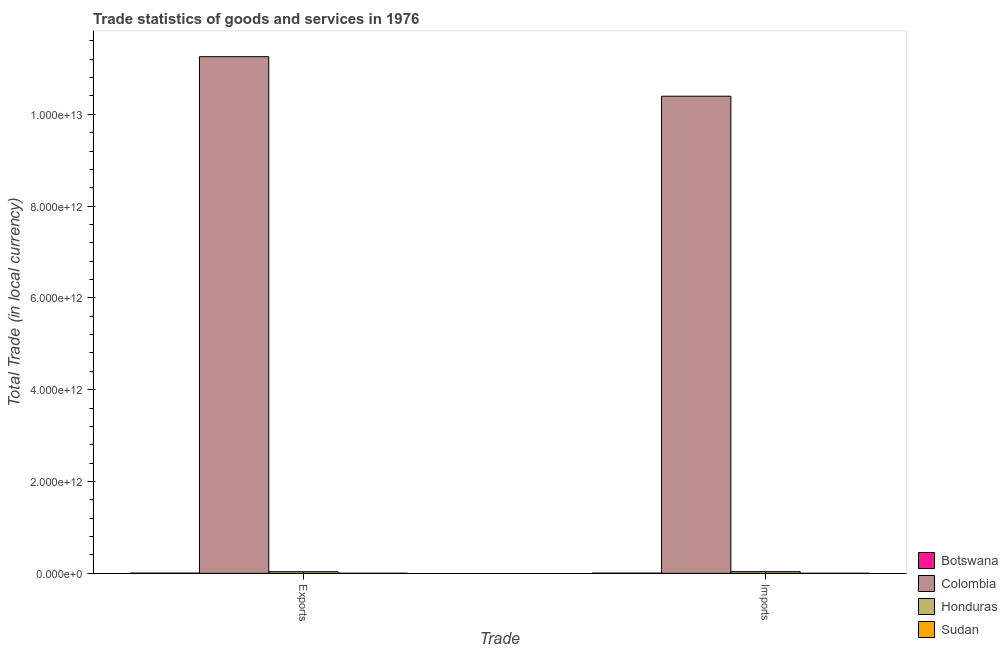How many groups of bars are there?
Offer a very short reply. 2. What is the label of the 2nd group of bars from the left?
Provide a short and direct response. Imports. What is the export of goods and services in Honduras?
Keep it short and to the point. 3.53e+1. Across all countries, what is the maximum export of goods and services?
Keep it short and to the point. 1.13e+13. Across all countries, what is the minimum imports of goods and services?
Offer a terse response. 1.31e+09. In which country was the export of goods and services minimum?
Make the answer very short. Sudan. What is the total imports of goods and services in the graph?
Your answer should be very brief. 1.04e+13. What is the difference between the export of goods and services in Honduras and that in Sudan?
Keep it short and to the point. 3.40e+1. What is the difference between the imports of goods and services in Honduras and the export of goods and services in Sudan?
Provide a short and direct response. 3.54e+1. What is the average imports of goods and services per country?
Provide a succinct answer. 2.61e+12. What is the difference between the imports of goods and services and export of goods and services in Honduras?
Give a very brief answer. 1.37e+09. What is the ratio of the export of goods and services in Sudan to that in Botswana?
Give a very brief answer. 0.35. In how many countries, is the export of goods and services greater than the average export of goods and services taken over all countries?
Ensure brevity in your answer.  1. What does the 1st bar from the left in Imports represents?
Ensure brevity in your answer.  Botswana. What does the 1st bar from the right in Imports represents?
Your answer should be compact. Sudan. How many bars are there?
Make the answer very short. 8. Are all the bars in the graph horizontal?
Ensure brevity in your answer.  No. What is the difference between two consecutive major ticks on the Y-axis?
Your answer should be very brief. 2.00e+12. Are the values on the major ticks of Y-axis written in scientific E-notation?
Provide a short and direct response. Yes. Does the graph contain any zero values?
Your response must be concise. No. Does the graph contain grids?
Ensure brevity in your answer.  No. How many legend labels are there?
Provide a short and direct response. 4. How are the legend labels stacked?
Provide a succinct answer. Vertical. What is the title of the graph?
Offer a terse response. Trade statistics of goods and services in 1976. Does "New Caledonia" appear as one of the legend labels in the graph?
Ensure brevity in your answer.  No. What is the label or title of the X-axis?
Offer a very short reply. Trade. What is the label or title of the Y-axis?
Ensure brevity in your answer.  Total Trade (in local currency). What is the Total Trade (in local currency) of Botswana in Exports?
Ensure brevity in your answer.  3.53e+09. What is the Total Trade (in local currency) of Colombia in Exports?
Your answer should be compact. 1.13e+13. What is the Total Trade (in local currency) of Honduras in Exports?
Ensure brevity in your answer.  3.53e+1. What is the Total Trade (in local currency) in Sudan in Exports?
Keep it short and to the point. 1.23e+09. What is the Total Trade (in local currency) in Botswana in Imports?
Offer a terse response. 4.05e+09. What is the Total Trade (in local currency) in Colombia in Imports?
Offer a terse response. 1.04e+13. What is the Total Trade (in local currency) in Honduras in Imports?
Offer a terse response. 3.66e+1. What is the Total Trade (in local currency) of Sudan in Imports?
Ensure brevity in your answer.  1.31e+09. Across all Trade, what is the maximum Total Trade (in local currency) in Botswana?
Offer a very short reply. 4.05e+09. Across all Trade, what is the maximum Total Trade (in local currency) of Colombia?
Provide a short and direct response. 1.13e+13. Across all Trade, what is the maximum Total Trade (in local currency) of Honduras?
Ensure brevity in your answer.  3.66e+1. Across all Trade, what is the maximum Total Trade (in local currency) of Sudan?
Keep it short and to the point. 1.31e+09. Across all Trade, what is the minimum Total Trade (in local currency) in Botswana?
Offer a terse response. 3.53e+09. Across all Trade, what is the minimum Total Trade (in local currency) of Colombia?
Give a very brief answer. 1.04e+13. Across all Trade, what is the minimum Total Trade (in local currency) of Honduras?
Keep it short and to the point. 3.53e+1. Across all Trade, what is the minimum Total Trade (in local currency) of Sudan?
Your response must be concise. 1.23e+09. What is the total Total Trade (in local currency) of Botswana in the graph?
Your response must be concise. 7.58e+09. What is the total Total Trade (in local currency) in Colombia in the graph?
Give a very brief answer. 2.16e+13. What is the total Total Trade (in local currency) in Honduras in the graph?
Your answer should be compact. 7.19e+1. What is the total Total Trade (in local currency) in Sudan in the graph?
Provide a succinct answer. 2.55e+09. What is the difference between the Total Trade (in local currency) in Botswana in Exports and that in Imports?
Your response must be concise. -5.29e+08. What is the difference between the Total Trade (in local currency) of Colombia in Exports and that in Imports?
Your answer should be very brief. 8.62e+11. What is the difference between the Total Trade (in local currency) in Honduras in Exports and that in Imports?
Keep it short and to the point. -1.37e+09. What is the difference between the Total Trade (in local currency) in Sudan in Exports and that in Imports?
Your answer should be very brief. -8.14e+07. What is the difference between the Total Trade (in local currency) of Botswana in Exports and the Total Trade (in local currency) of Colombia in Imports?
Provide a short and direct response. -1.04e+13. What is the difference between the Total Trade (in local currency) of Botswana in Exports and the Total Trade (in local currency) of Honduras in Imports?
Your answer should be compact. -3.31e+1. What is the difference between the Total Trade (in local currency) in Botswana in Exports and the Total Trade (in local currency) in Sudan in Imports?
Make the answer very short. 2.21e+09. What is the difference between the Total Trade (in local currency) in Colombia in Exports and the Total Trade (in local currency) in Honduras in Imports?
Your answer should be very brief. 1.12e+13. What is the difference between the Total Trade (in local currency) in Colombia in Exports and the Total Trade (in local currency) in Sudan in Imports?
Give a very brief answer. 1.13e+13. What is the difference between the Total Trade (in local currency) of Honduras in Exports and the Total Trade (in local currency) of Sudan in Imports?
Ensure brevity in your answer.  3.39e+1. What is the average Total Trade (in local currency) of Botswana per Trade?
Give a very brief answer. 3.79e+09. What is the average Total Trade (in local currency) of Colombia per Trade?
Your answer should be compact. 1.08e+13. What is the average Total Trade (in local currency) of Honduras per Trade?
Your answer should be very brief. 3.59e+1. What is the average Total Trade (in local currency) in Sudan per Trade?
Your response must be concise. 1.27e+09. What is the difference between the Total Trade (in local currency) in Botswana and Total Trade (in local currency) in Colombia in Exports?
Your answer should be compact. -1.13e+13. What is the difference between the Total Trade (in local currency) in Botswana and Total Trade (in local currency) in Honduras in Exports?
Ensure brevity in your answer.  -3.17e+1. What is the difference between the Total Trade (in local currency) in Botswana and Total Trade (in local currency) in Sudan in Exports?
Make the answer very short. 2.29e+09. What is the difference between the Total Trade (in local currency) of Colombia and Total Trade (in local currency) of Honduras in Exports?
Give a very brief answer. 1.12e+13. What is the difference between the Total Trade (in local currency) of Colombia and Total Trade (in local currency) of Sudan in Exports?
Give a very brief answer. 1.13e+13. What is the difference between the Total Trade (in local currency) of Honduras and Total Trade (in local currency) of Sudan in Exports?
Ensure brevity in your answer.  3.40e+1. What is the difference between the Total Trade (in local currency) of Botswana and Total Trade (in local currency) of Colombia in Imports?
Offer a very short reply. -1.04e+13. What is the difference between the Total Trade (in local currency) in Botswana and Total Trade (in local currency) in Honduras in Imports?
Offer a very short reply. -3.26e+1. What is the difference between the Total Trade (in local currency) of Botswana and Total Trade (in local currency) of Sudan in Imports?
Ensure brevity in your answer.  2.74e+09. What is the difference between the Total Trade (in local currency) in Colombia and Total Trade (in local currency) in Honduras in Imports?
Offer a terse response. 1.04e+13. What is the difference between the Total Trade (in local currency) in Colombia and Total Trade (in local currency) in Sudan in Imports?
Offer a terse response. 1.04e+13. What is the difference between the Total Trade (in local currency) in Honduras and Total Trade (in local currency) in Sudan in Imports?
Your response must be concise. 3.53e+1. What is the ratio of the Total Trade (in local currency) in Botswana in Exports to that in Imports?
Give a very brief answer. 0.87. What is the ratio of the Total Trade (in local currency) in Colombia in Exports to that in Imports?
Provide a short and direct response. 1.08. What is the ratio of the Total Trade (in local currency) in Honduras in Exports to that in Imports?
Keep it short and to the point. 0.96. What is the ratio of the Total Trade (in local currency) of Sudan in Exports to that in Imports?
Provide a succinct answer. 0.94. What is the difference between the highest and the second highest Total Trade (in local currency) of Botswana?
Offer a terse response. 5.29e+08. What is the difference between the highest and the second highest Total Trade (in local currency) of Colombia?
Keep it short and to the point. 8.62e+11. What is the difference between the highest and the second highest Total Trade (in local currency) of Honduras?
Your response must be concise. 1.37e+09. What is the difference between the highest and the second highest Total Trade (in local currency) in Sudan?
Your answer should be compact. 8.14e+07. What is the difference between the highest and the lowest Total Trade (in local currency) in Botswana?
Give a very brief answer. 5.29e+08. What is the difference between the highest and the lowest Total Trade (in local currency) of Colombia?
Offer a terse response. 8.62e+11. What is the difference between the highest and the lowest Total Trade (in local currency) in Honduras?
Provide a short and direct response. 1.37e+09. What is the difference between the highest and the lowest Total Trade (in local currency) of Sudan?
Give a very brief answer. 8.14e+07. 